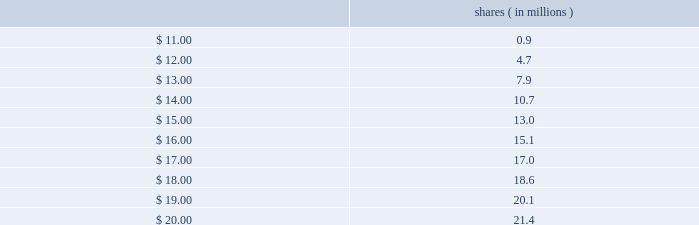All highly liquid securities with a maturity of three months or less at the date of purchase are considered to be cash equivalents .
Securities with maturities greater than three months are classified as available-for-sale and are considered to be short-term investments .
The carrying value of our interest-bearing instruments approximated fair value as of december 29 , 2012 .
Interest rates under our revolving credit facility are variable , so interest expense for periods when the credit facility is utilized could be adversely affected by changes in interest rates .
Interest rates under our revolving credit facility can fluctuate based on changes in market interest rates and in an interest rate margin that varies based on our consolidated leverage ratio .
As of december 29 , 2012 , we had no outstanding balance on the credit facility .
See note 3 in the notes to consolidated financial statements for an additional description of our credit facility .
Equity price risk convertible notes our 2015 notes and 2013 notes include conversion and settlement provisions that are based on the price of our common stock at conversion or at maturity of the notes .
In addition , the hedges and warrants associated with these convertible notes also include settlement provisions that are based on the price of our common stock .
The amount of cash we may be required to pay , or the number of shares we may be required to provide to note holders at conversion or maturity of these notes , is determined by the price of our common stock .
The amount of cash or number of shares that we may receive from hedge counterparties in connection with the related hedges and the number of shares that we may be required to provide warrant counterparties in connection with the related warrants are also determined by the price of our common stock .
Upon the expiration of our 2015 warrants , cadence will issue shares of common stock to the purchasers of the warrants to the extent our stock price exceeds the warrant strike price of $ 10.78 at that time .
The table shows the number of shares that cadence would issue to 2015 warrant counterparties at expiration of the warrants , assuming various cadence closing stock prices on the dates of warrant expiration : shares ( in millions ) .
Prior to the expiration of the 2015 warrants , for purposes of calculating diluted earnings per share , our diluted weighted-average shares outstanding will increase when our average closing stock price for a quarter exceeds $ 10.78 .
For an additional description of our 2015 notes and 2013 notes , see note 3 in the notes to consolidated financial statements and 201cliquidity and capital resources 2014 other factors affecting liquidity and capital resources , 201d under item 7 , 201cmanagement 2019s discussion and analysis of financial condition and results of operations . 201d .
What is the percentage difference in the number of shares to be issued if the stock price closes at $ 11 compared to if it closes at $ 20? 
Computations: ((21.4 - 0.9) / 0.9)
Answer: 22.77778. 